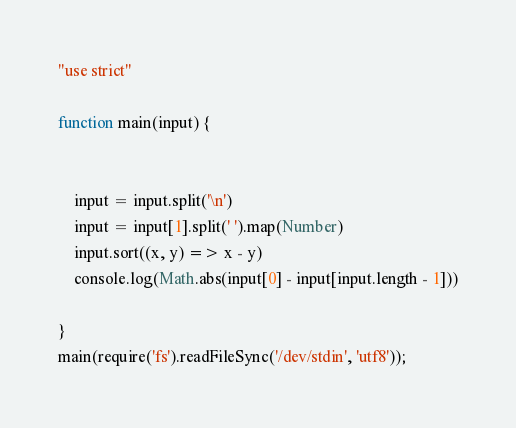<code> <loc_0><loc_0><loc_500><loc_500><_JavaScript_>"use strict"

function main(input) {


    input = input.split('\n')
    input = input[1].split(' ').map(Number)
    input.sort((x, y) => x - y)
    console.log(Math.abs(input[0] - input[input.length - 1]))

}
main(require('fs').readFileSync('/dev/stdin', 'utf8'));</code> 